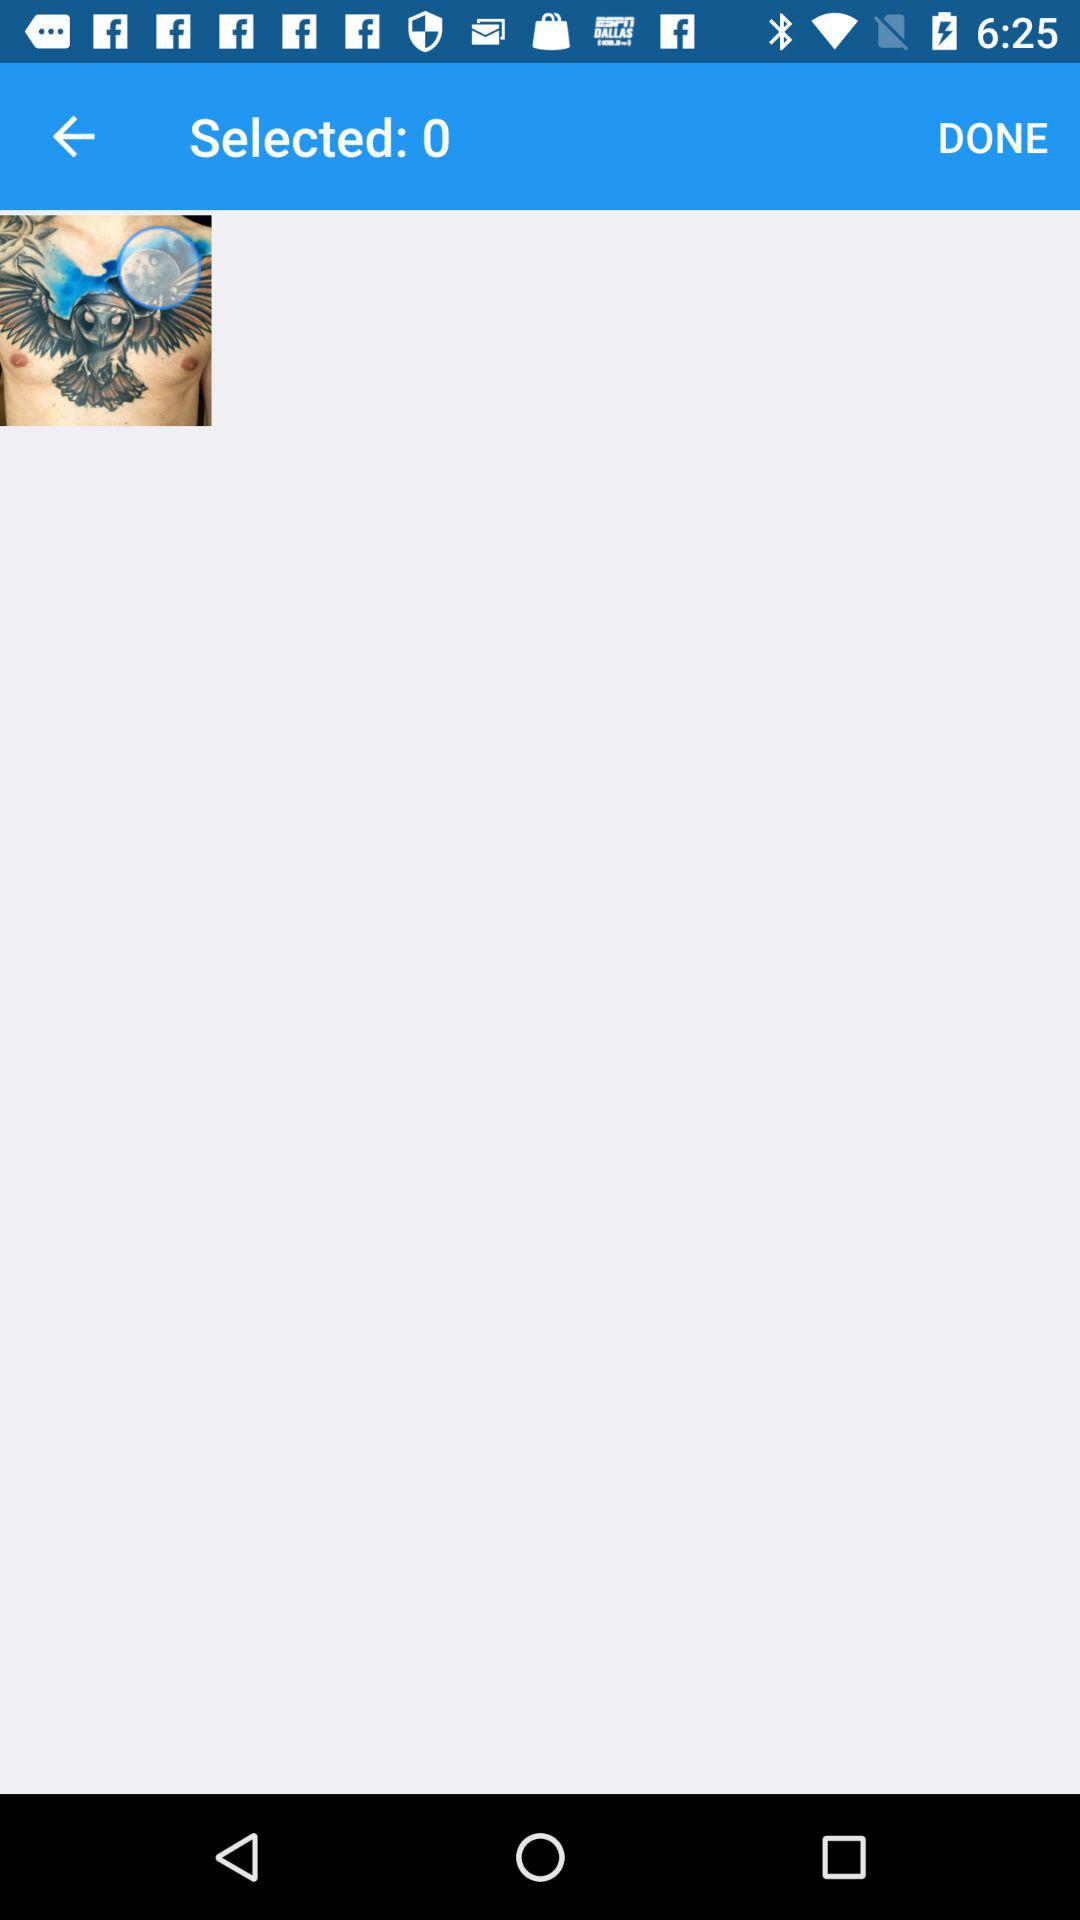Who posted the image?
When the provided information is insufficient, respond with <no answer>. <no answer> 